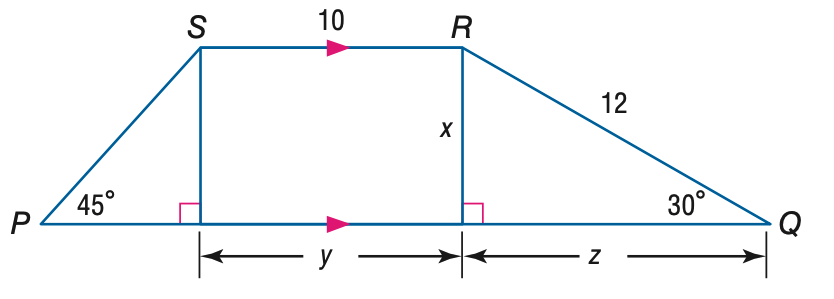Answer the mathemtical geometry problem and directly provide the correct option letter.
Question: Find y.
Choices: A: 6 B: 8 C: 10 D: 12 C 